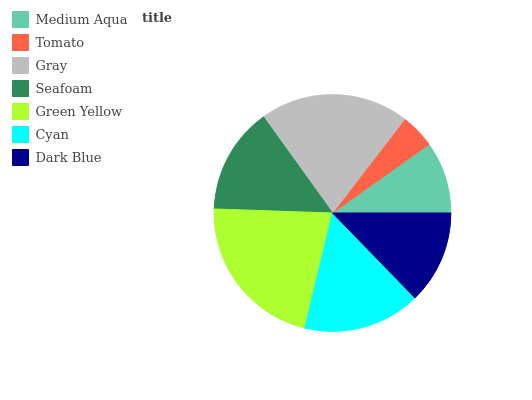Is Tomato the minimum?
Answer yes or no. Yes. Is Green Yellow the maximum?
Answer yes or no. Yes. Is Gray the minimum?
Answer yes or no. No. Is Gray the maximum?
Answer yes or no. No. Is Gray greater than Tomato?
Answer yes or no. Yes. Is Tomato less than Gray?
Answer yes or no. Yes. Is Tomato greater than Gray?
Answer yes or no. No. Is Gray less than Tomato?
Answer yes or no. No. Is Seafoam the high median?
Answer yes or no. Yes. Is Seafoam the low median?
Answer yes or no. Yes. Is Cyan the high median?
Answer yes or no. No. Is Dark Blue the low median?
Answer yes or no. No. 